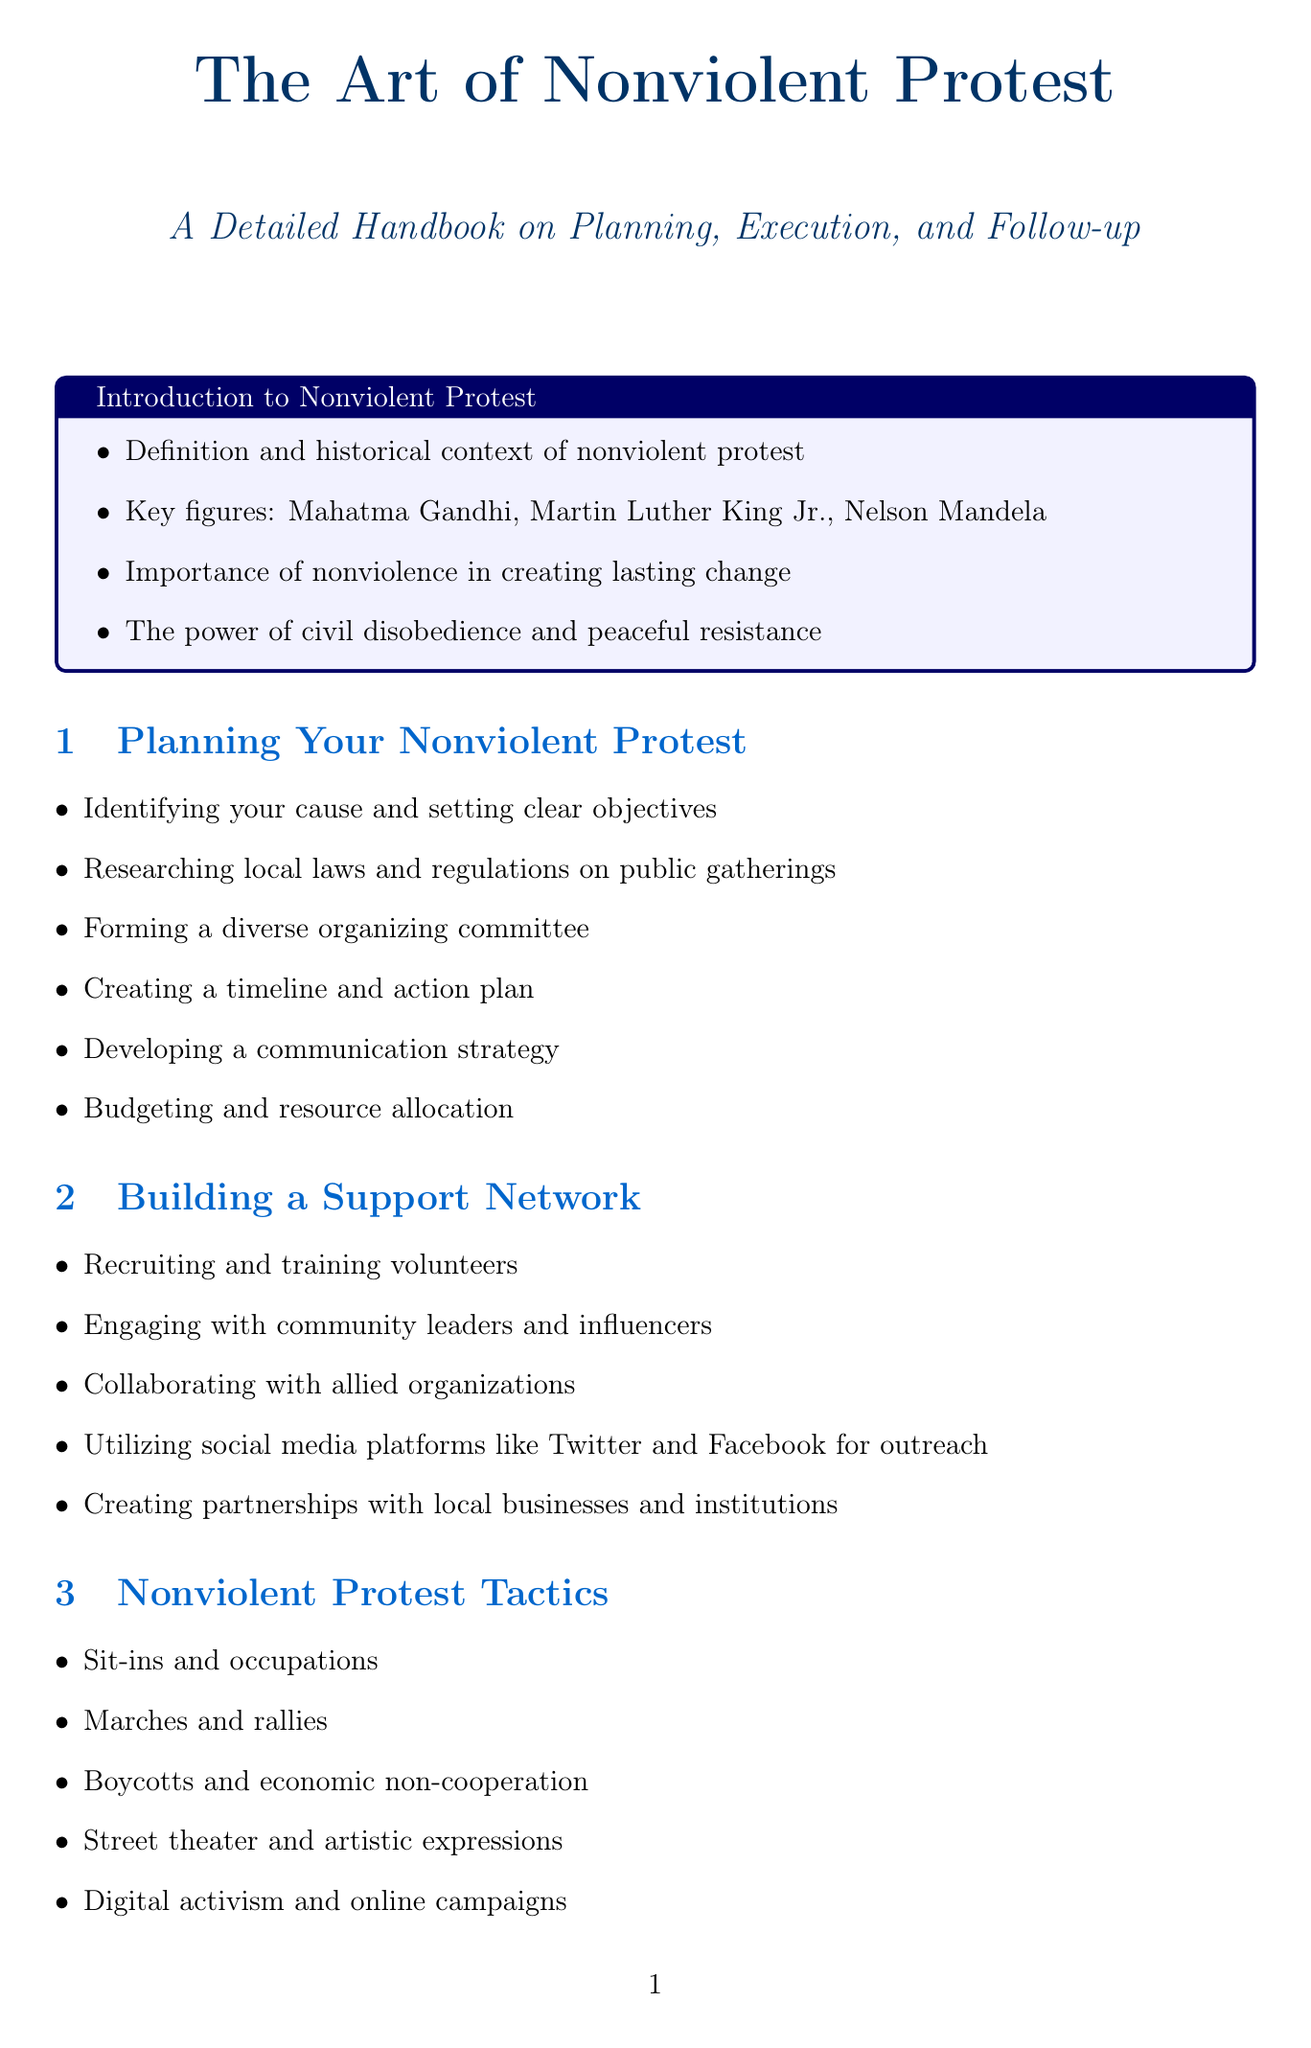What is the first section of the manual? The first section provides an introduction to the topic and defines nonviolent protest, along with its historical context.
Answer: Introduction to Nonviolent Protest Who are the key figures mentioned in the introduction? The introduction highlights significant leaders known for their nonviolent strategies in their movements.
Answer: Mahatma Gandhi, Martin Luther King Jr., Nelson Mandela What is one of the tactics used in nonviolent protest? The manual lists specific actions that can be taken during the protest, with each representing different methods of peaceful resistance.
Answer: Sit-ins and occupations What should you establish for potential arrests during protests? The manual advises on preparation for legal matters that could arise from public demonstrations.
Answer: Legal support team How can you maintain momentum after a protest? Continued engagement is suggested as a strategy to keep the cause alive after the initial action has taken place.
Answer: Continued engagement What is the last section in the manual? The manual concludes with suggestions of resources that readers can explore for further understanding of nonviolent protest.
Answer: Resources for Further Learning 